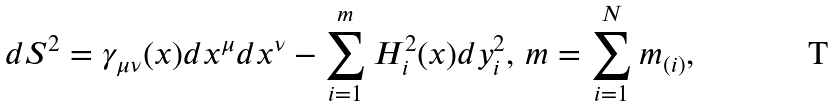<formula> <loc_0><loc_0><loc_500><loc_500>d S ^ { 2 } = \gamma _ { \mu \nu } ( x ) d x ^ { \mu } d x ^ { \nu } - \sum _ { i = 1 } ^ { m } H _ { i } ^ { 2 } ( x ) d y _ { i } ^ { 2 } , \, m = \sum _ { i = 1 } ^ { N } { m _ { ( i ) } } ,</formula> 